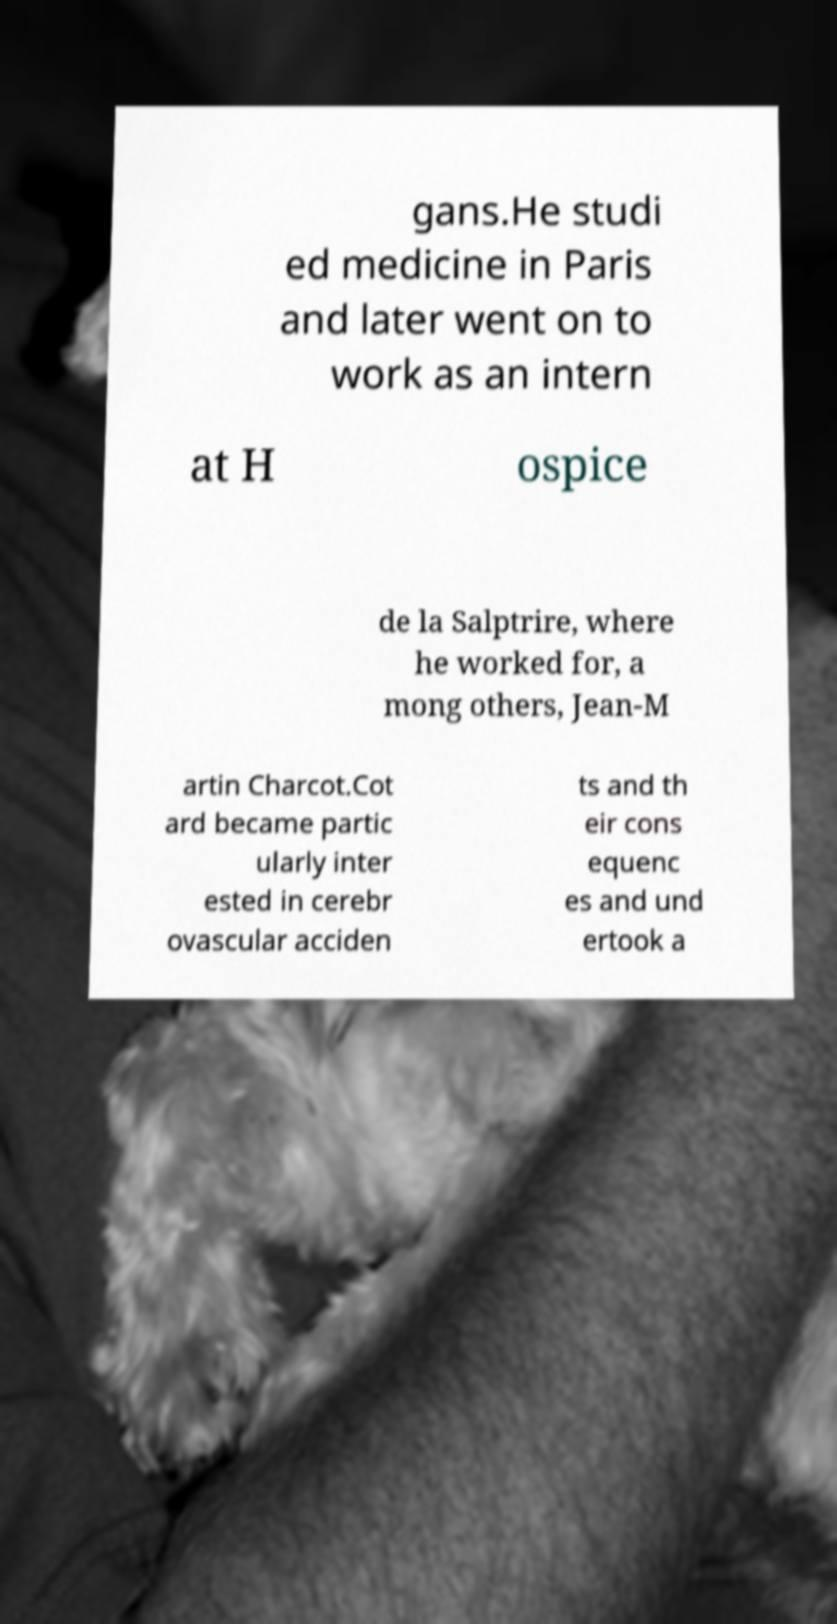Can you accurately transcribe the text from the provided image for me? gans.He studi ed medicine in Paris and later went on to work as an intern at H ospice de la Salptrire, where he worked for, a mong others, Jean-M artin Charcot.Cot ard became partic ularly inter ested in cerebr ovascular acciden ts and th eir cons equenc es and und ertook a 